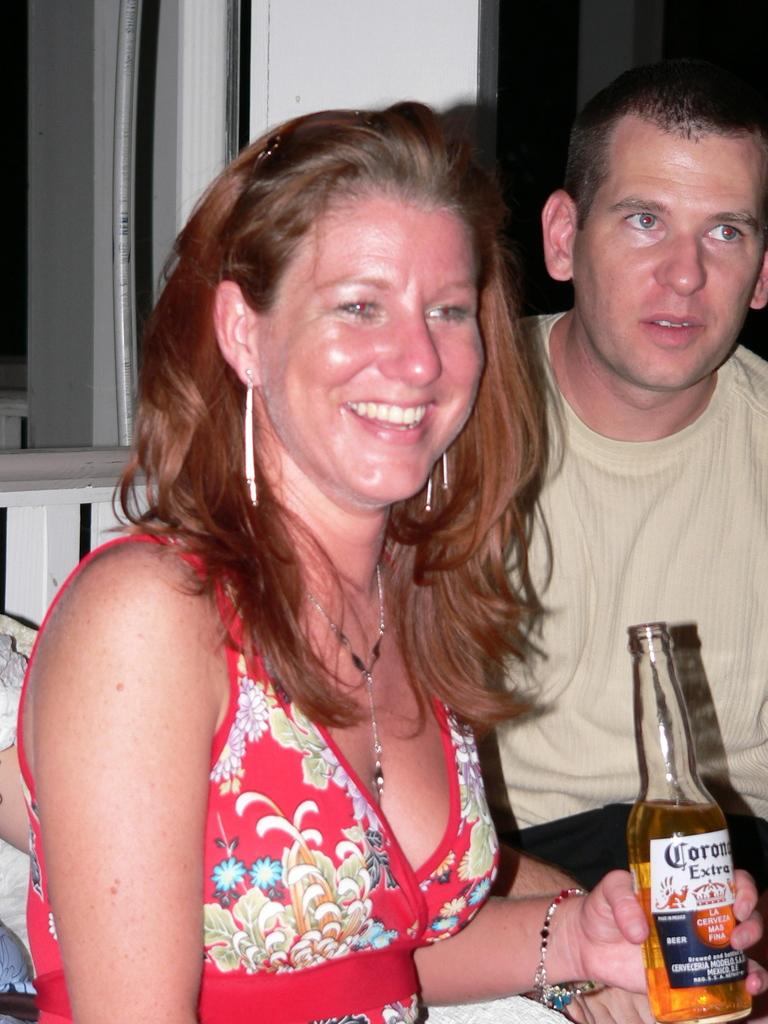What are the two people in the image doing? There is a man and a woman in the image, and the woman is laughing. What is the woman holding in her hand? The woman is holding a bottle in her hand. What can be seen in the background of the image? There is a window visible in the background of the image. What type of necklace is the woman wearing in the image? There is no necklace visible in the image; the woman is holding a bottle in her hand. 